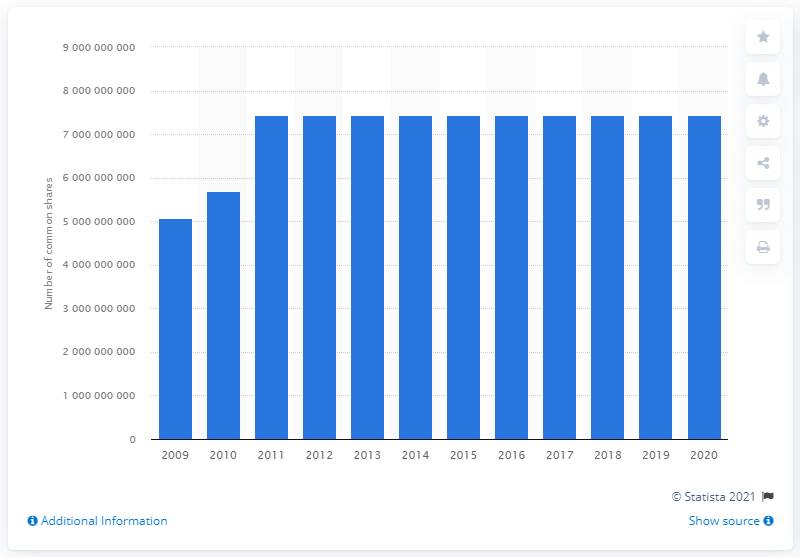Give some essential details in this illustration. In 2020, Petrobras reported a total of 7,442,231,382 common shares. 